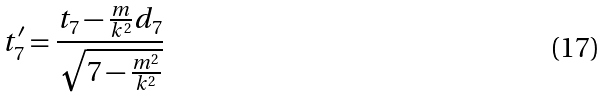<formula> <loc_0><loc_0><loc_500><loc_500>t _ { 7 } ^ { \prime } = \frac { t _ { 7 } - \frac { m } { k ^ { 2 } } d _ { 7 } } { \sqrt { 7 - \frac { m ^ { 2 } } { k ^ { 2 } } } }</formula> 